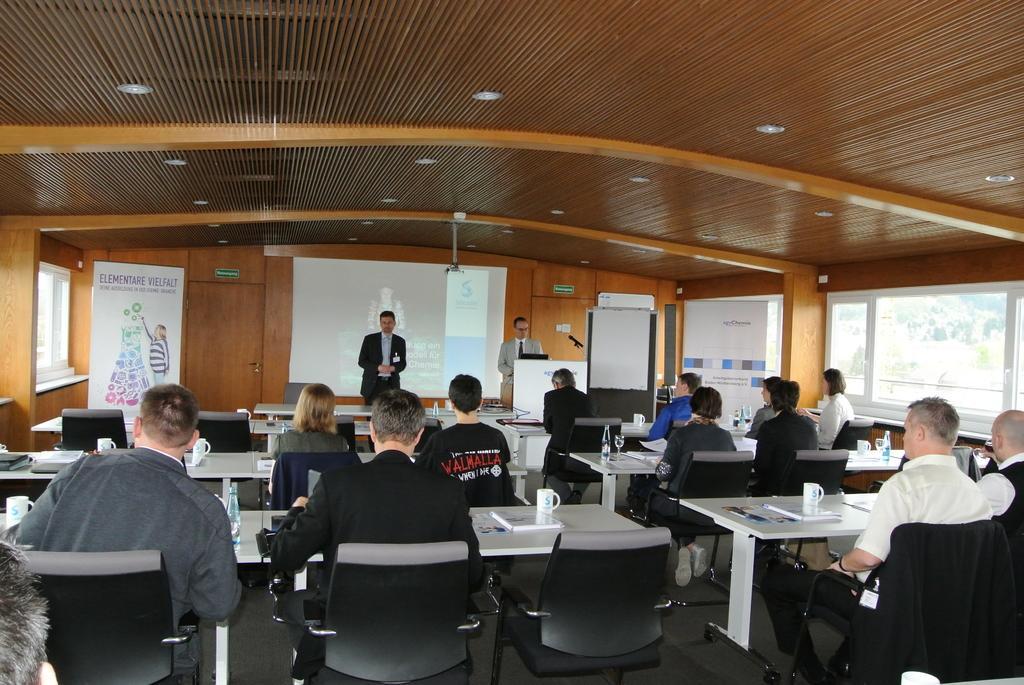Describe this image in one or two sentences. In this image I can see number of people were two of them are standing and all are sitting. In the background I can see a white screen. 